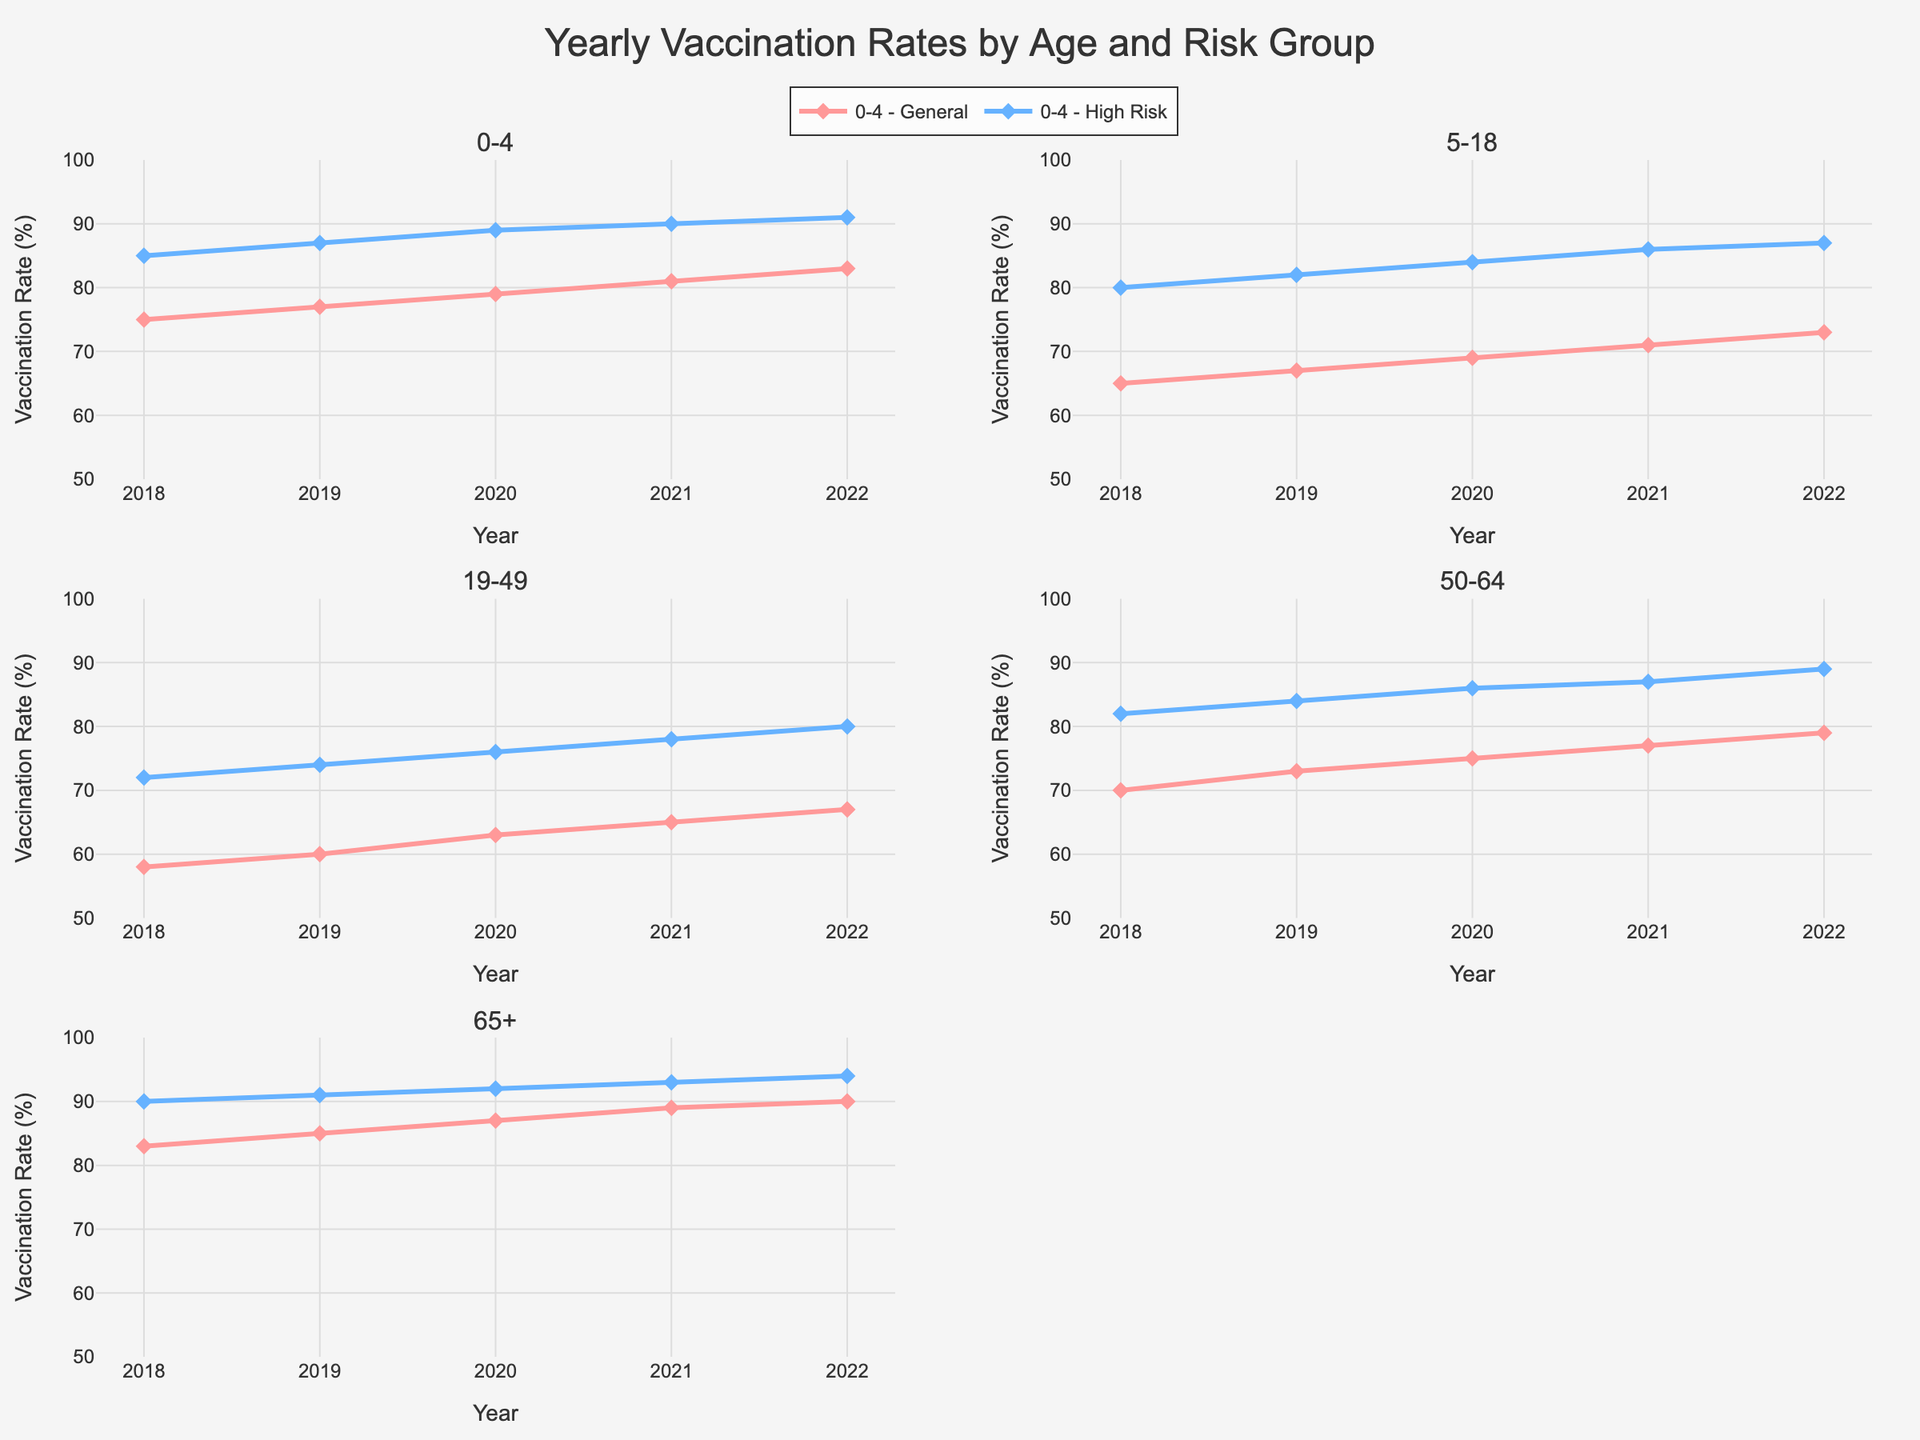What is the title of the figure? The title of the figure is located at the top center of the chart. By examining the figure, you can see that the title reads "Yearly Vaccination Rates by Age and Risk Group".
Answer: Yearly Vaccination Rates by Age and Risk Group What is the range of the y-axis? The y-axis range typically starts at the bottom left and extends to the top of the chart. By looking at the y-axis label and values, we can see that it ranges from 50 to 100 percent.
Answer: 50 to 100 Which age group has the highest vaccination rate in 2022? The highest vaccination rate can be found by comparing the values at 2022 for each age group. By examining the data points for 2022, we see the 65+ High Risk group has a rate of 94%, which is the highest.
Answer: 65+ High Risk For the 19-49 age group, how does the vaccination rate trend for the General risk group from 2018 to 2022? A trend can be identified by observing the direction of values for the General risk group from 2018 to 2022. The rate starts at 58% in 2018 and gradually increases to 67% in 2022, showing an upward trend.
Answer: Upward trend Which subgroup shows the most consistent increase in vaccination rates year over year? To determine consistency, one must look at whether the values increase each year without dropping. By inspecting the subplots, it becomes clear that the 0-4 High Risk group increases steadily from 85% in 2018 to 91% in 2022 without any drops.
Answer: 0-4 High Risk How much did the vaccination rate for the 50-64 High Risk group increase from 2018 to 2022? The vaccination rate for the 50-64 High Risk group can be found by looking at the values for 2018 and 2022. In 2018, it was 82% and in 2022 it increased to 89%. The difference is 89% - 82% = 7%.
Answer: 7% Which age group shows the largest difference in vaccination rates between the General and High Risk groups in 2022? To find the largest difference, we compare the General and High Risk rates for each age group in 2022. The largest difference is seen in the 19-49 age group, where General is at 67% and High Risk is at 80%, a difference of 13 percentage points.
Answer: 19-49 Among the General risk groups, which had the lowest vaccination rate in 2019? We look at the General risk group data points for 2019 across all age groups. The 19-49 General risk group has the lowest rate at 60%.
Answer: 19-49 What is the average vaccination rate for the 5-18 High Risk group over the five years? To calculate the average, sum up the vaccination rates from 2018 to 2022 and divide by the number of years. (80 + 82 + 84 + 86 + 87) / 5 = 419 / 5 = 83.8%.
Answer: 83.8% Does any age group show a decline in vaccination rates for any year within the given period? To detect a decline, compare the rates year-by-year for each age group. The 19-49 General risk group shows a decline from 2020 to 2019, dropping from 63% to 60%.
Answer: 19-49 General 